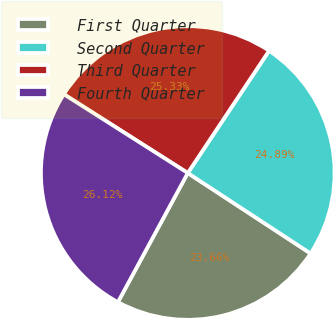Convert chart to OTSL. <chart><loc_0><loc_0><loc_500><loc_500><pie_chart><fcel>First Quarter<fcel>Second Quarter<fcel>Third Quarter<fcel>Fourth Quarter<nl><fcel>23.66%<fcel>24.89%<fcel>25.33%<fcel>26.12%<nl></chart> 